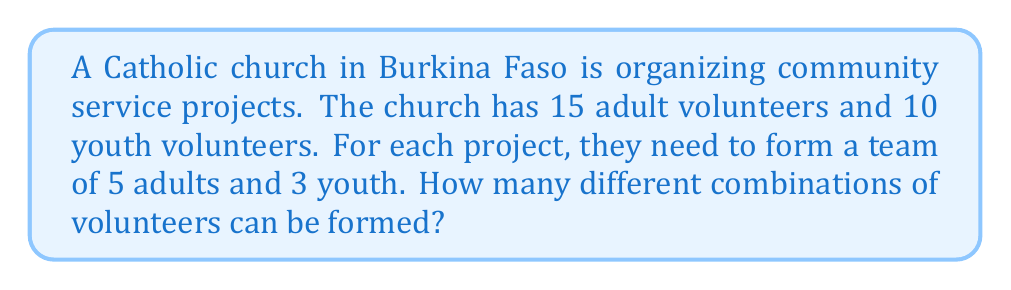Can you answer this question? To solve this problem, we need to use the combination formula for both the adult and youth groups, then multiply the results.

1. For the adult volunteers:
   We need to choose 5 adults out of 15. This can be represented as $C(15,5)$ or $\binom{15}{5}$.
   $$\binom{15}{5} = \frac{15!}{5!(15-5)!} = \frac{15!}{5!10!}$$

2. For the youth volunteers:
   We need to choose 3 youth out of 10. This can be represented as $C(10,3)$ or $\binom{10}{3}$.
   $$\binom{10}{3} = \frac{10!}{3!(10-3)!} = \frac{10!}{3!7!}$$

3. Calculate $\binom{15}{5}$:
   $$\binom{15}{5} = \frac{15 \cdot 14 \cdot 13 \cdot 12 \cdot 11}{5 \cdot 4 \cdot 3 \cdot 2 \cdot 1} = 3003$$

4. Calculate $\binom{10}{3}$:
   $$\binom{10}{3} = \frac{10 \cdot 9 \cdot 8}{3 \cdot 2 \cdot 1} = 120$$

5. The total number of possible combinations is the product of these two results:
   $$3003 \cdot 120 = 360,360$$

Therefore, there are 360,360 different possible combinations of volunteers that can be formed.
Answer: 360,360 